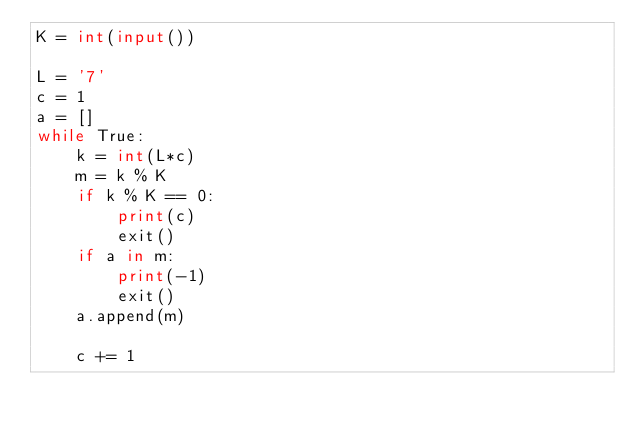Convert code to text. <code><loc_0><loc_0><loc_500><loc_500><_Python_>K = int(input())

L = '7'
c = 1
a = []
while True:
    k = int(L*c)
    m = k % K
    if k % K == 0:
        print(c)
        exit()
    if a in m:
        print(-1)
        exit()
    a.append(m)
    
    c += 1</code> 